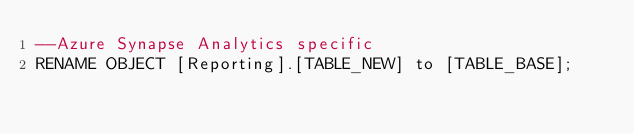<code> <loc_0><loc_0><loc_500><loc_500><_SQL_>--Azure Synapse Analytics specific
RENAME OBJECT [Reporting].[TABLE_NEW] to [TABLE_BASE];

</code> 